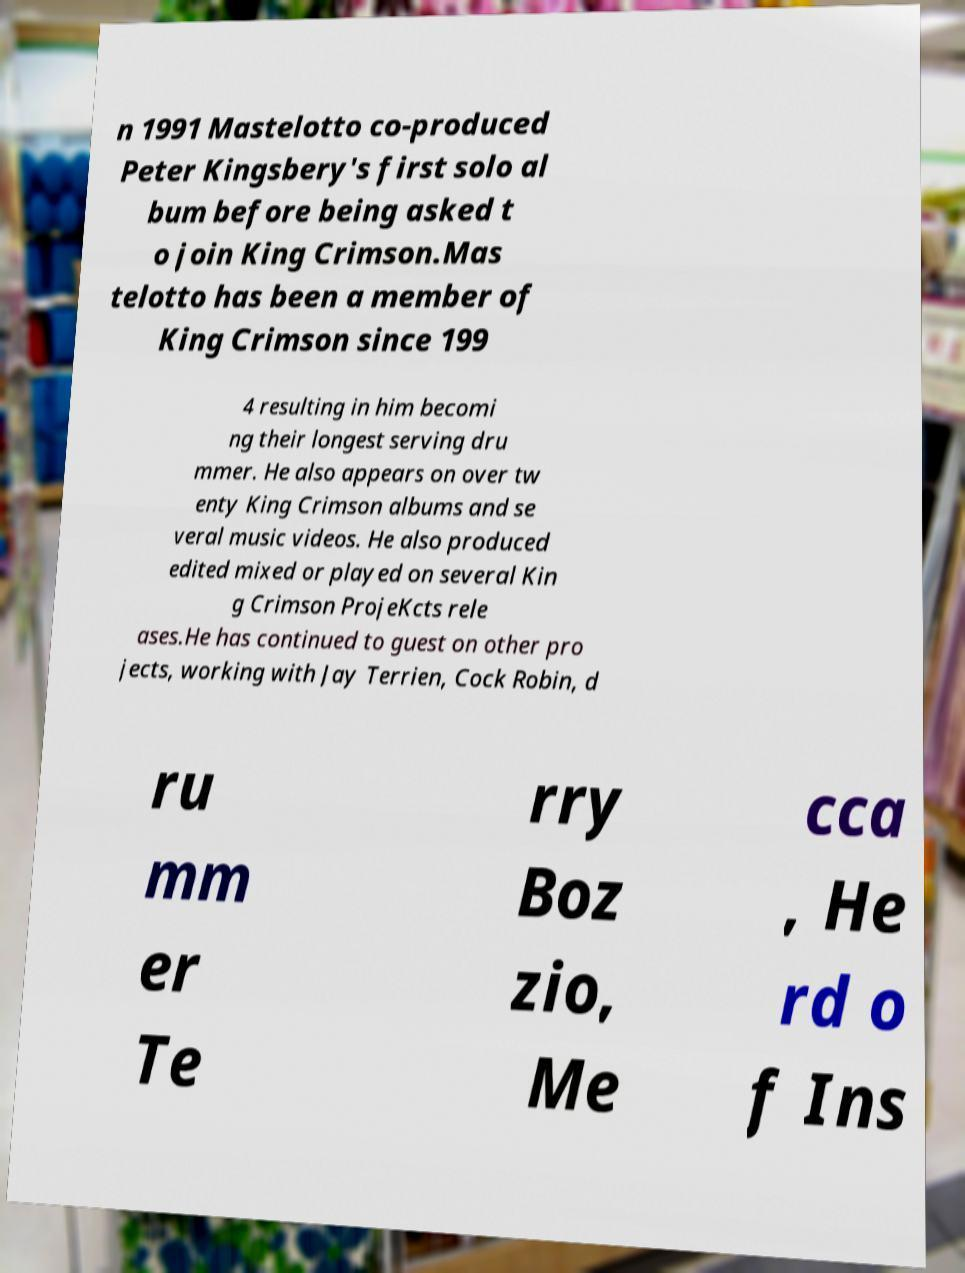Please read and relay the text visible in this image. What does it say? n 1991 Mastelotto co-produced Peter Kingsbery's first solo al bum before being asked t o join King Crimson.Mas telotto has been a member of King Crimson since 199 4 resulting in him becomi ng their longest serving dru mmer. He also appears on over tw enty King Crimson albums and se veral music videos. He also produced edited mixed or played on several Kin g Crimson ProjeKcts rele ases.He has continued to guest on other pro jects, working with Jay Terrien, Cock Robin, d ru mm er Te rry Boz zio, Me cca , He rd o f Ins 